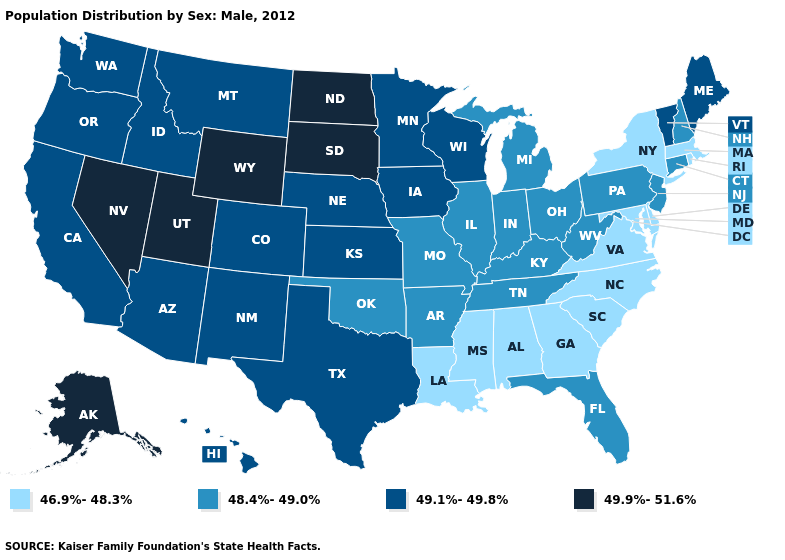Name the states that have a value in the range 46.9%-48.3%?
Be succinct. Alabama, Delaware, Georgia, Louisiana, Maryland, Massachusetts, Mississippi, New York, North Carolina, Rhode Island, South Carolina, Virginia. Does Vermont have the lowest value in the Northeast?
Give a very brief answer. No. What is the highest value in states that border New Mexico?
Give a very brief answer. 49.9%-51.6%. Which states hav the highest value in the South?
Quick response, please. Texas. Name the states that have a value in the range 49.1%-49.8%?
Be succinct. Arizona, California, Colorado, Hawaii, Idaho, Iowa, Kansas, Maine, Minnesota, Montana, Nebraska, New Mexico, Oregon, Texas, Vermont, Washington, Wisconsin. What is the value of Illinois?
Answer briefly. 48.4%-49.0%. What is the lowest value in the USA?
Keep it brief. 46.9%-48.3%. Does Iowa have a lower value than Alaska?
Write a very short answer. Yes. What is the highest value in states that border Virginia?
Concise answer only. 48.4%-49.0%. Among the states that border Oklahoma , which have the lowest value?
Give a very brief answer. Arkansas, Missouri. What is the lowest value in the USA?
Keep it brief. 46.9%-48.3%. Name the states that have a value in the range 48.4%-49.0%?
Concise answer only. Arkansas, Connecticut, Florida, Illinois, Indiana, Kentucky, Michigan, Missouri, New Hampshire, New Jersey, Ohio, Oklahoma, Pennsylvania, Tennessee, West Virginia. What is the lowest value in the Northeast?
Quick response, please. 46.9%-48.3%. What is the value of Alaska?
Be succinct. 49.9%-51.6%. Which states have the lowest value in the MidWest?
Short answer required. Illinois, Indiana, Michigan, Missouri, Ohio. 